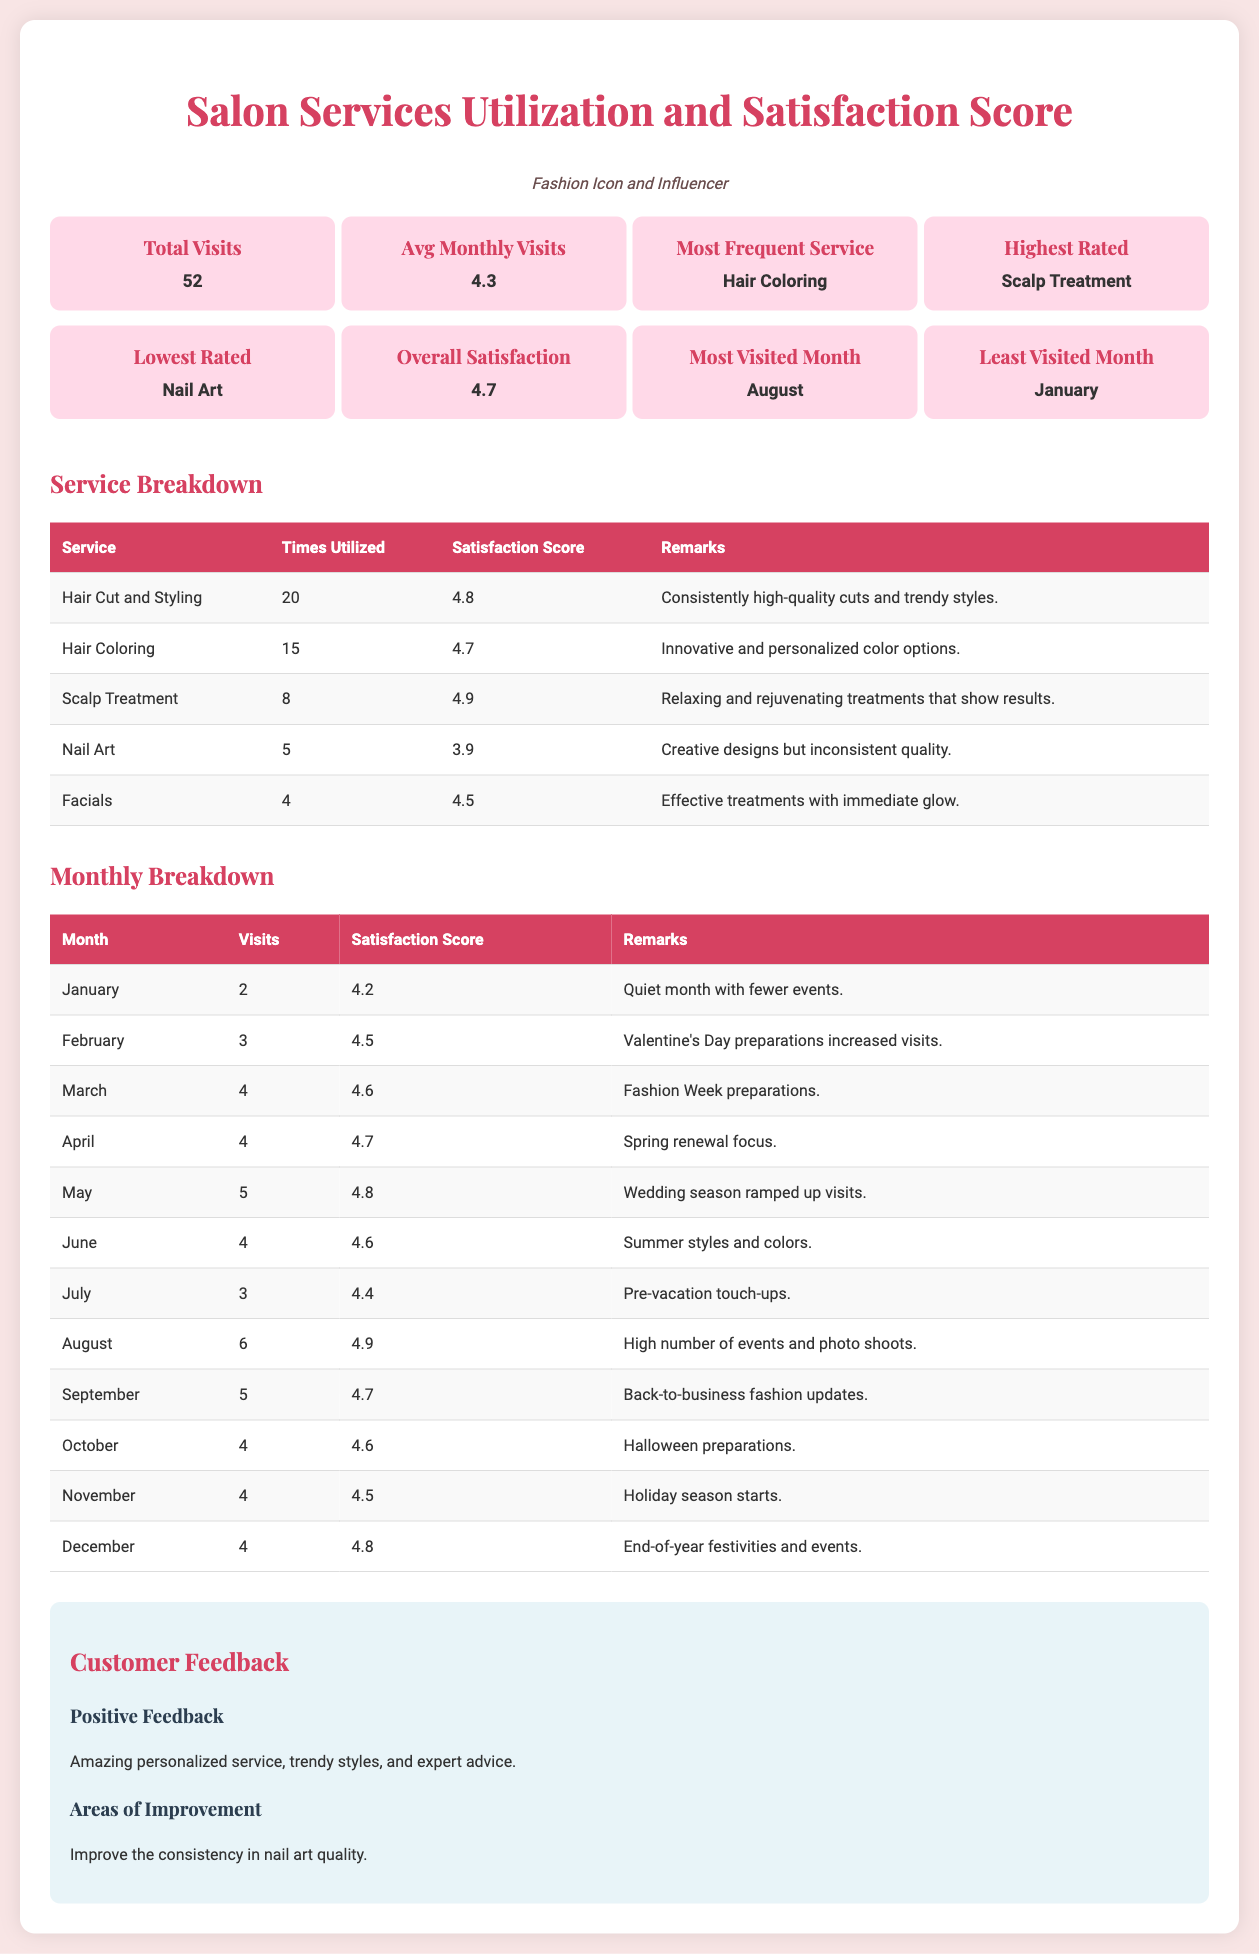What is the total number of visits? The total number of visits is indicated in the key metrics section of the document as 52.
Answer: 52 What was the highest rated service? The highest rated service can be found in the key metrics section, which states that the Scalp Treatment is the highest rated.
Answer: Scalp Treatment How many times was Hair Coloring utilized? The number of times Hair Coloring was utilized is listed in the Service Breakdown table as 15.
Answer: 15 What is the average satisfaction score for January? The average satisfaction score for January is detailed in the Monthly Breakdown table, which shows it as 4.2.
Answer: 4.2 Which month had the highest number of visits? The month with the highest number of visits is August, as indicated in the Monthly Breakdown table with 6 visits.
Answer: August What service had the lowest satisfaction score? The lowest satisfaction score is specified in the key metrics section, which indicates Nail Art as the lowest rated service.
Answer: Nail Art How many visits were recorded in May? The number of visits in May can be found in the Monthly Breakdown table, showing 5 visits.
Answer: 5 What service received 4.8 for satisfaction score? The satisfaction score for the service that received 4.8 is listed under Hair Cut and Styling in the Service Breakdown table.
Answer: Hair Cut and Styling What is the remark for the Scalp Treatment? The remark for the Scalp Treatment is provided in the Service Breakdown table and states it is relaxing and rejuvenating.
Answer: Relaxing and rejuvenating treatments that show results 